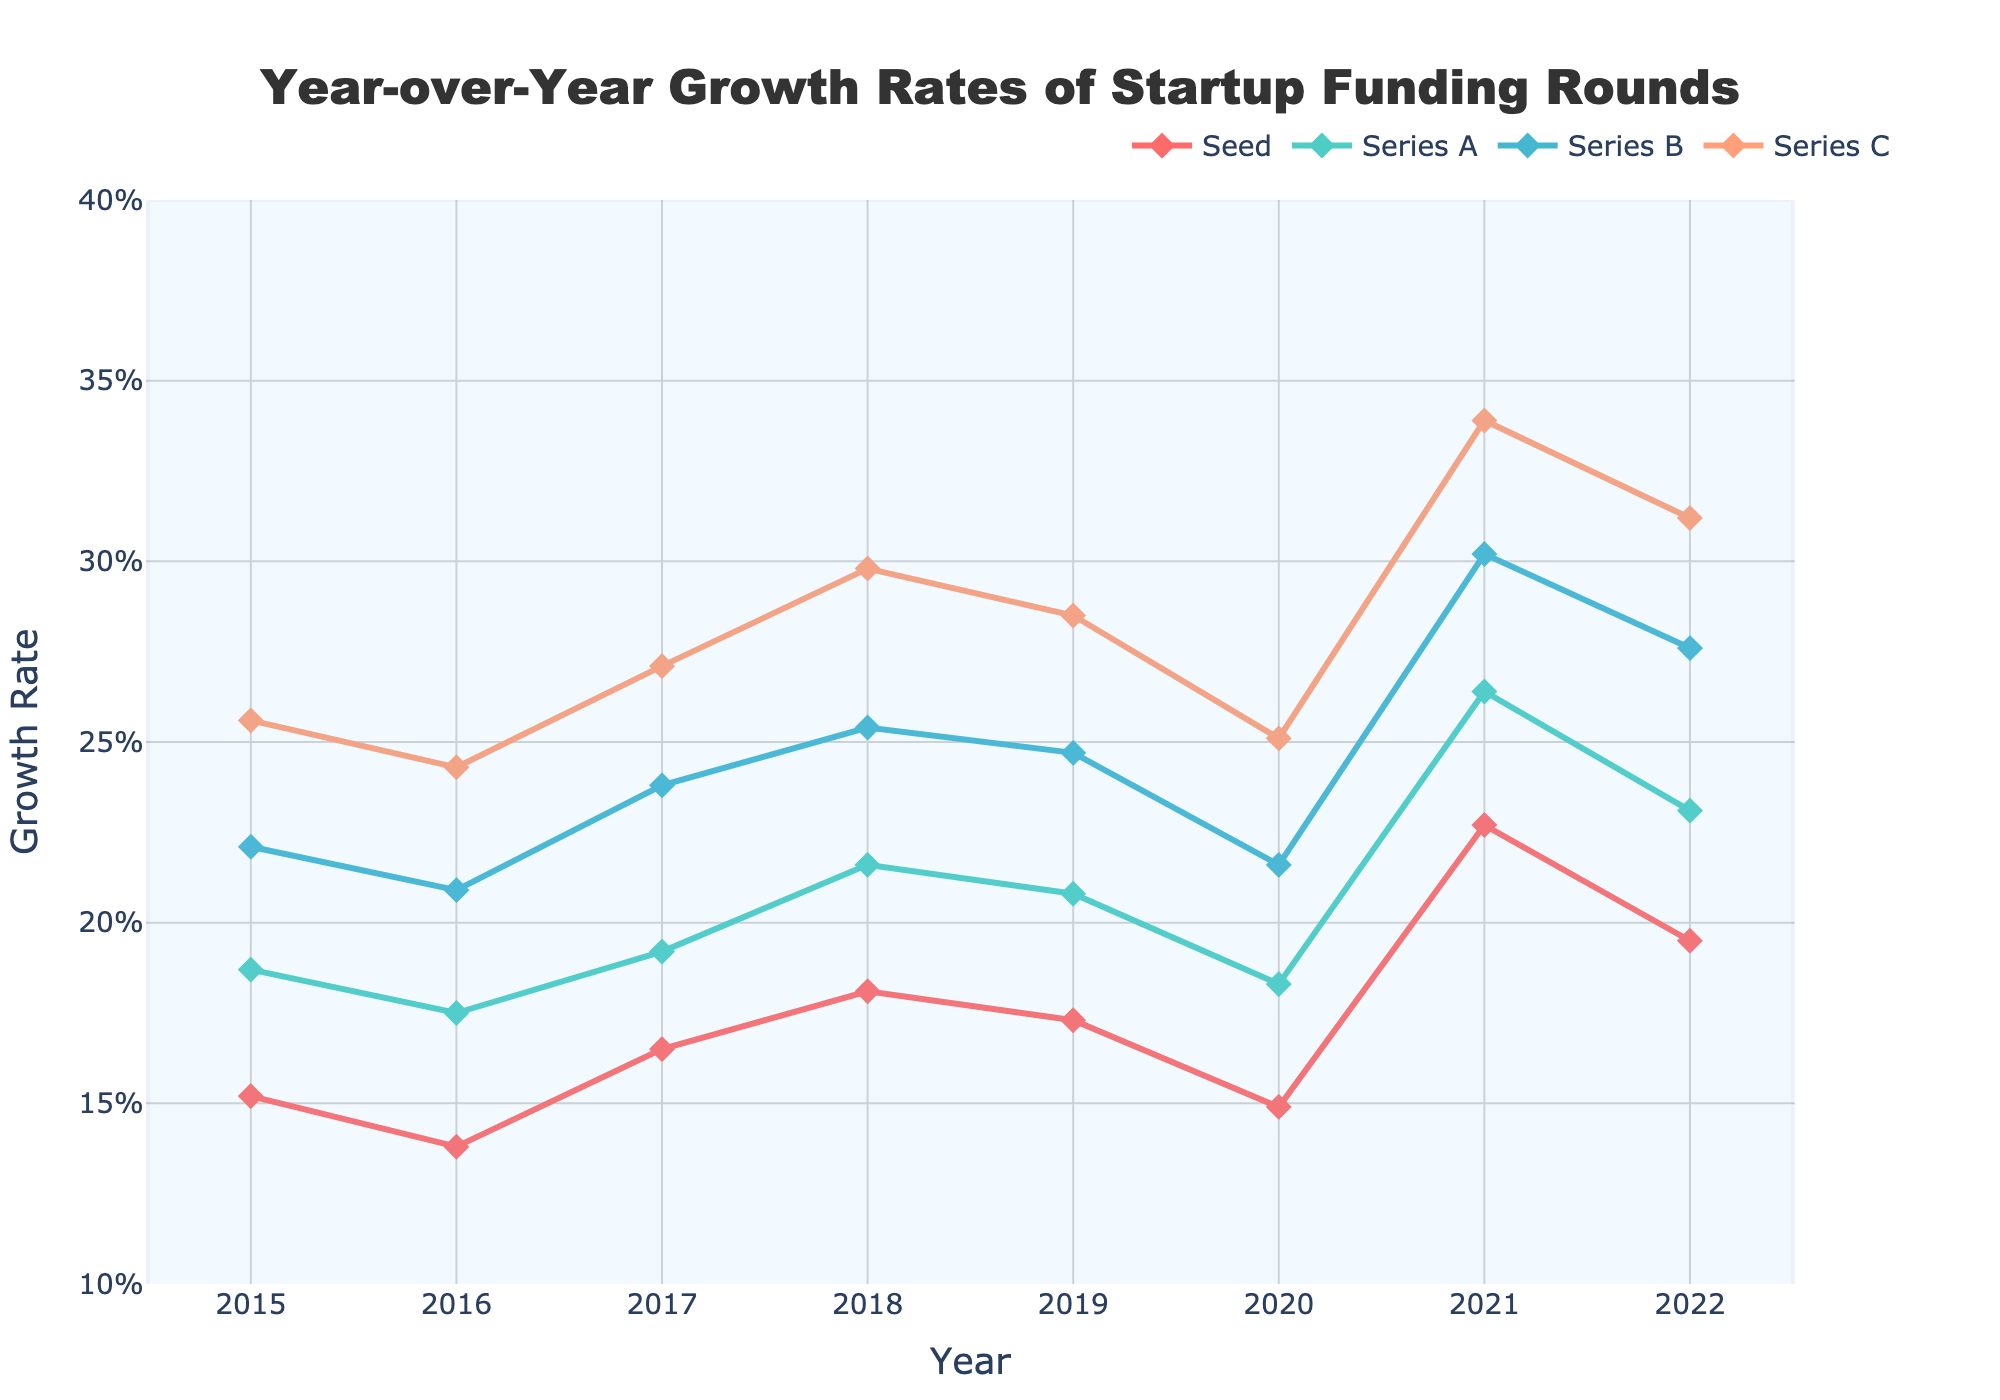What was the growth rate for Series A in 2021? We look up the value corresponding to Series A in the year 2021.
Answer: 26.4% Which funding round had the highest growth rate in 2020? By comparing the growth rates of all funding rounds for 2020, we see that Series C had the highest growth rate.
Answer: Series C By how much did the Seed funding round growth rate change from 2019 to 2020? We subtract the 2020 growth rate of Seed funding (14.9%) from the 2019 growth rate (17.3%). The calculation is 17.3% - 14.9%.
Answer: 2.4% How did the growth rate for Series B in 2022 compare to its rate in 2015? By comparing the two values, we see the growth rate for Series B in 2022 (27.6%) was higher than in 2015 (22.1%).
Answer: Higher What's the average growth rate of Series C from 2015 to 2022? Average = (25.6% + 24.3% + 27.1% + 29.8% + 28.5% + 25.1% + 33.9% + 31.2%) / 8. The sum of these rates is 225.5%. The average is 225.5% / 8.
Answer: 28.2% Which year showed the highest growth rate for any funding round, and for which round? By inspecting the maximum values, we find that 2021 had the highest growth rate, and it was for Series C at 33.9%.
Answer: 2021, Series C Was there any year where all four funding rounds saw a decrease in growth rates compared to the previous year? By evaluating changes year-by-year, only the year 2020 saw a decrease in all funding rounds compared to 2019.
Answer: 2020 How does the growth rate trend for Seed funding compare to Series A between 2016 and 2019? Both trends generally increase from 2016 to 2018 but dip again in 2019. Seed funding increased from 13.8% to 18.1% before falling to 17.3%, and Series A grew from 17.5% to 21.6% before dropping to 20.8%.
Answer: Similar trend What's the difference in the growth rate of Series B between its highest and lowest years? The highest rate is in 2021 (30.2%), and the lowest is in 2016 (20.9%). The difference is 30.2% - 20.9%.
Answer: 9.3% Which funding round showed the most consistent growth rates from 2015 to 2022? Consistency is measured by the smallest changes in growth rate year by year. Series C shows the most steady growth between 25.1% and 33.9%.
Answer: Series C 